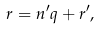<formula> <loc_0><loc_0><loc_500><loc_500>r = n ^ { \prime } q + r ^ { \prime } ,</formula> 